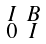<formula> <loc_0><loc_0><loc_500><loc_500>\begin{smallmatrix} I & B \\ 0 & I \end{smallmatrix}</formula> 